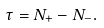<formula> <loc_0><loc_0><loc_500><loc_500>\tau = N _ { + } - N _ { - } .</formula> 